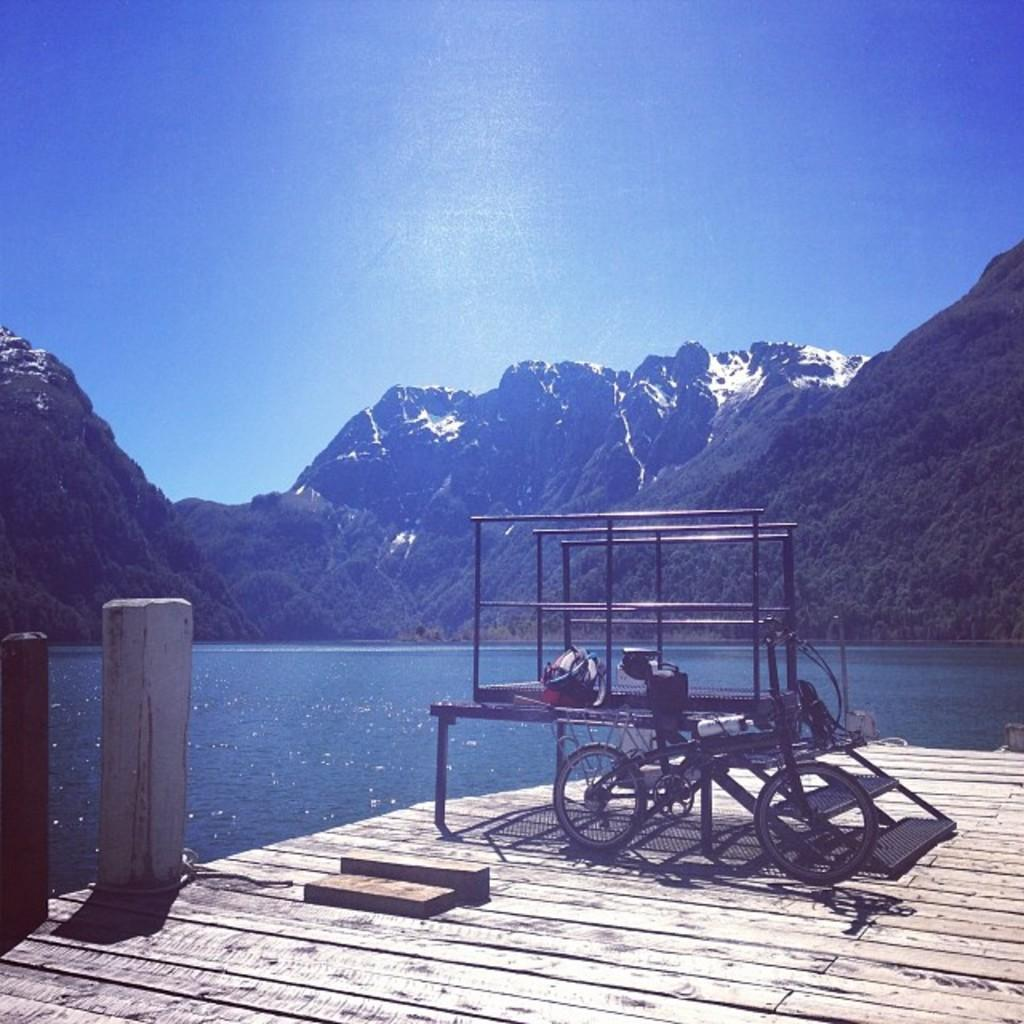What is the color of the object in the image? The object in the image is black. What type of surface is the black object resting on? The black object is on a wooden surface. What can be seen in the background of the image? Water and mountains are visible in the background of the image. How many sheep are visible in the image? There are no sheep present in the image. Can you describe the ant's behavior in the image? There is no ant present in the image. 